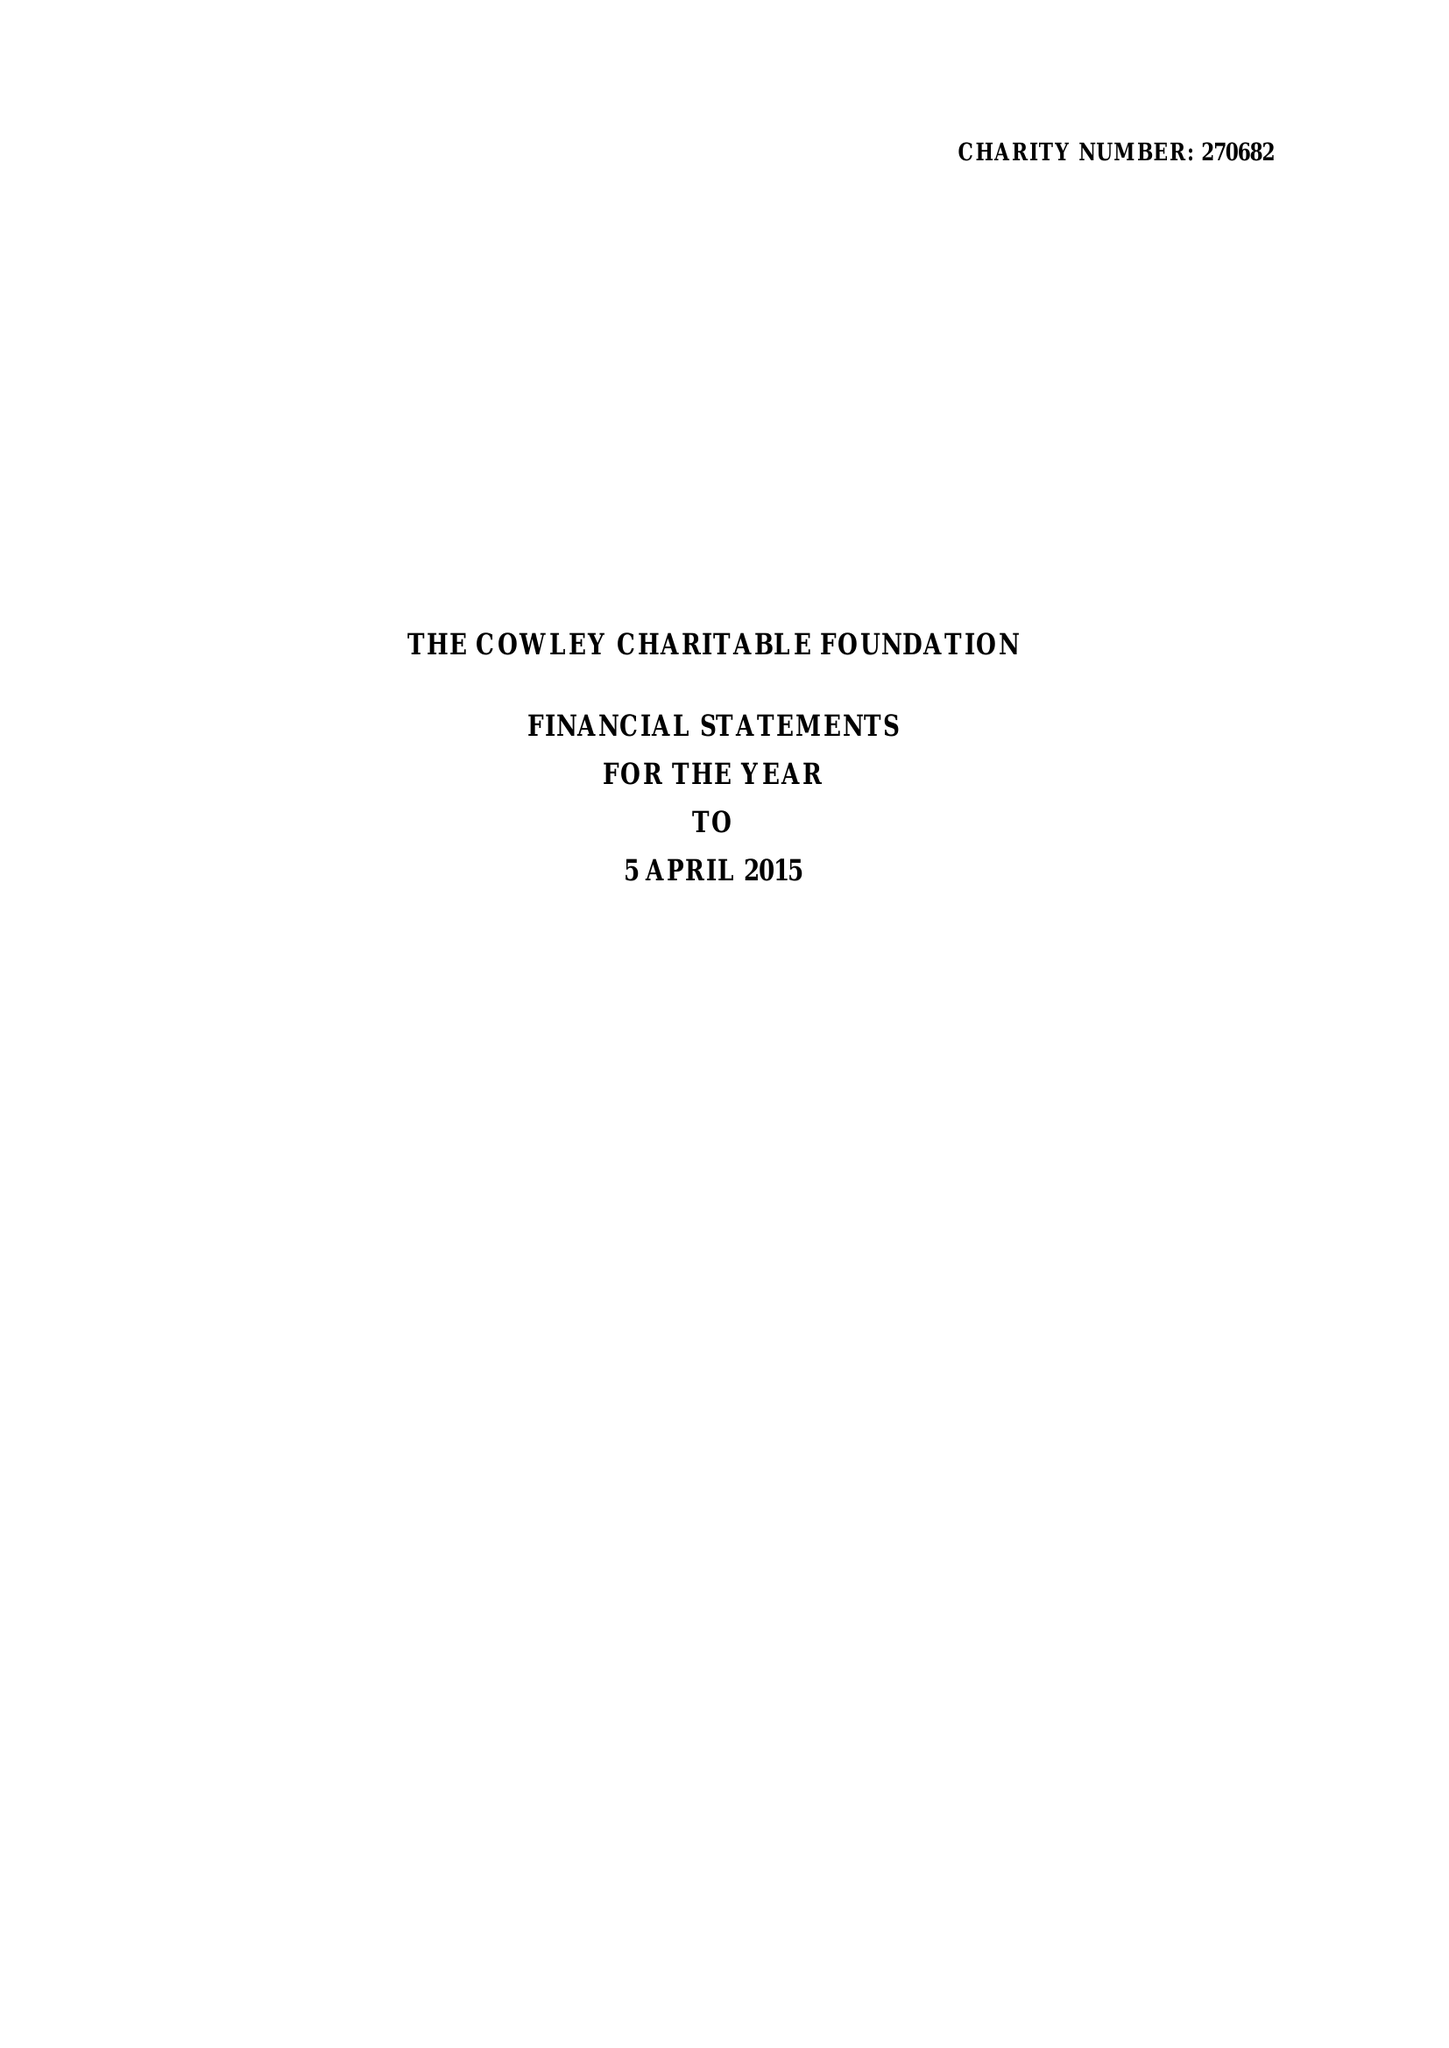What is the value for the report_date?
Answer the question using a single word or phrase. 2015-04-05 